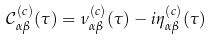Convert formula to latex. <formula><loc_0><loc_0><loc_500><loc_500>\mathcal { C } _ { \alpha \beta } ^ { ( c ) } ( \tau ) = \nu ^ { ( c ) } _ { \alpha \beta } ( \tau ) - i \eta ^ { ( c ) } _ { \alpha \beta } ( \tau )</formula> 